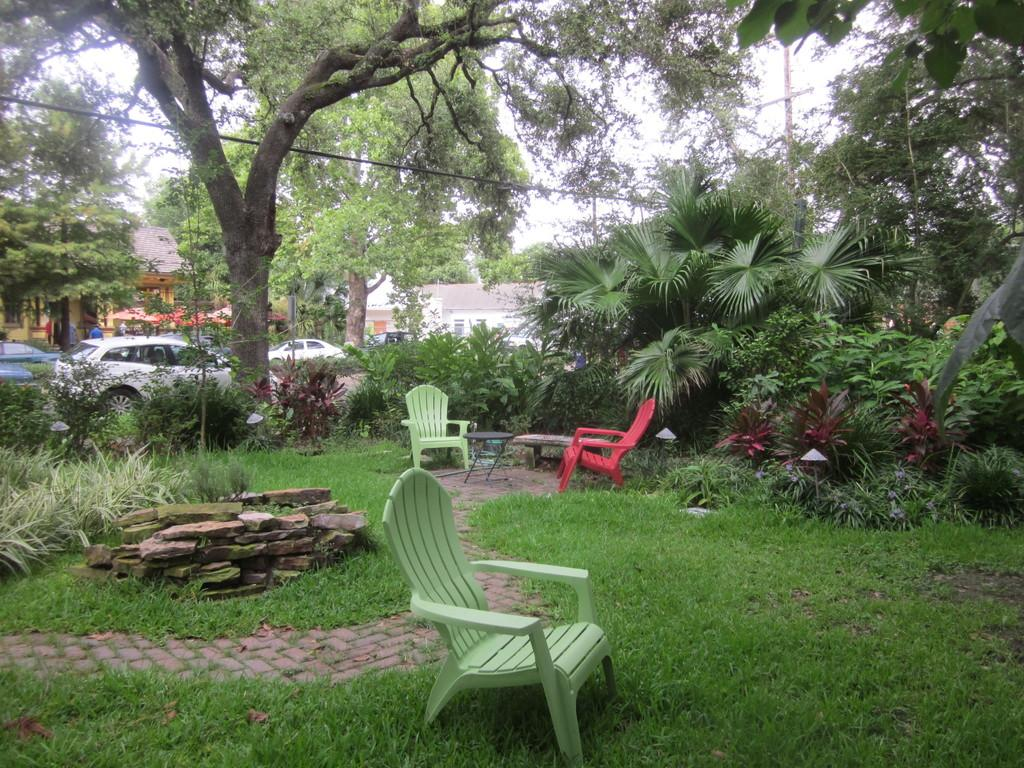What type of furniture can be seen in the image? There are chairs, a coffee table, and a bench in the image. What type of natural elements are present in the image? There are stones, plants, trees, grass, and a path in the image. What type of structures can be seen in the image? There are houses and vehicles in the image. What part of the natural environment is visible in the image? The sky is visible in the image. What additional object can be seen in the image? There is a wire in the image. Can you tell me how many cacti are depicted on the bench in the image? There are no cacti present in the image, and therefore no such activity can be observed. What type of magic is being performed by the trees in the image? There is no magic being performed by the trees in the image; they are simply trees in a natural environment. 